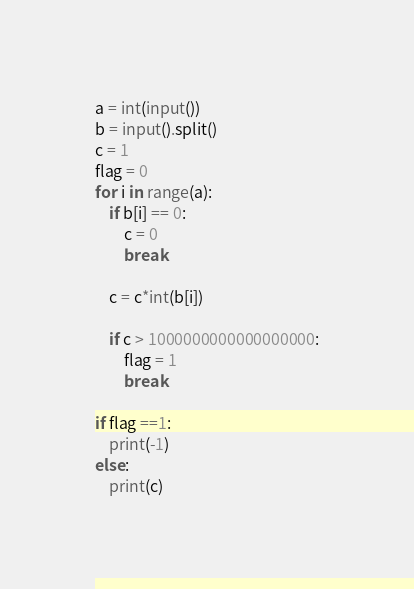<code> <loc_0><loc_0><loc_500><loc_500><_Python_>a = int(input())
b = input().split()
c = 1
flag = 0
for i in range(a):
    if b[i] == 0:
        c = 0
        break

    c = c*int(b[i])
            
    if c > 1000000000000000000:
        flag = 1
        break

if flag ==1:
    print(-1)
else:
    print(c)</code> 